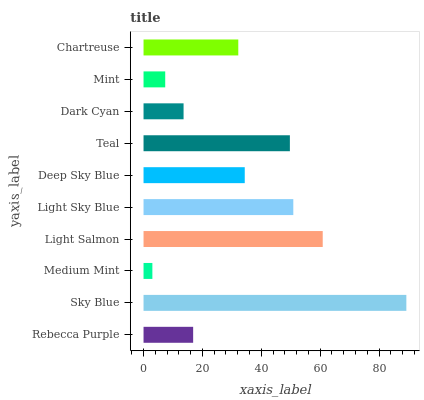Is Medium Mint the minimum?
Answer yes or no. Yes. Is Sky Blue the maximum?
Answer yes or no. Yes. Is Sky Blue the minimum?
Answer yes or no. No. Is Medium Mint the maximum?
Answer yes or no. No. Is Sky Blue greater than Medium Mint?
Answer yes or no. Yes. Is Medium Mint less than Sky Blue?
Answer yes or no. Yes. Is Medium Mint greater than Sky Blue?
Answer yes or no. No. Is Sky Blue less than Medium Mint?
Answer yes or no. No. Is Deep Sky Blue the high median?
Answer yes or no. Yes. Is Chartreuse the low median?
Answer yes or no. Yes. Is Sky Blue the high median?
Answer yes or no. No. Is Deep Sky Blue the low median?
Answer yes or no. No. 